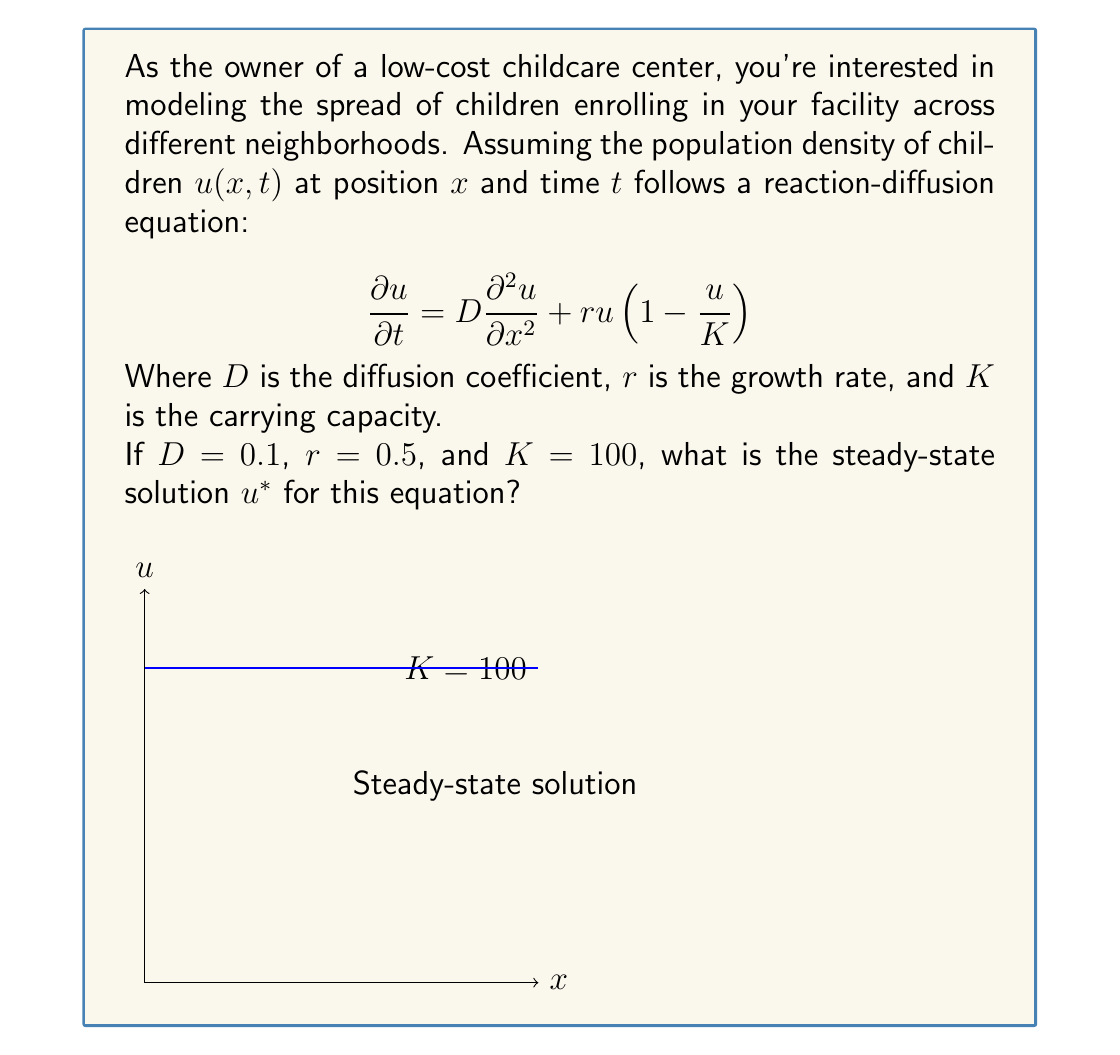Can you solve this math problem? To find the steady-state solution, we need to set the time derivative to zero:

$$\frac{\partial u}{\partial t} = 0$$

This gives us:

$$0 = D\frac{\partial^2 u}{\partial x^2} + ru(1-\frac{u}{K})$$

For a homogeneous steady-state solution, we assume that $u$ doesn't depend on $x$, so $\frac{\partial^2 u}{\partial x^2} = 0$. This simplifies our equation to:

$$0 = ru(1-\frac{u}{K})$$

Solving this equation:

1) $u = 0$ (trivial solution)
2) $1-\frac{u}{K} = 0$

From the second equation:

$$1-\frac{u}{K} = 0$$
$$-\frac{u}{K} = -1$$
$$u = K$$

Therefore, the non-trivial steady-state solution is $u^* = K = 100$.

This solution represents the carrying capacity, which is the maximum sustainable population density in your childcare center's service area.
Answer: $u^* = 100$ 